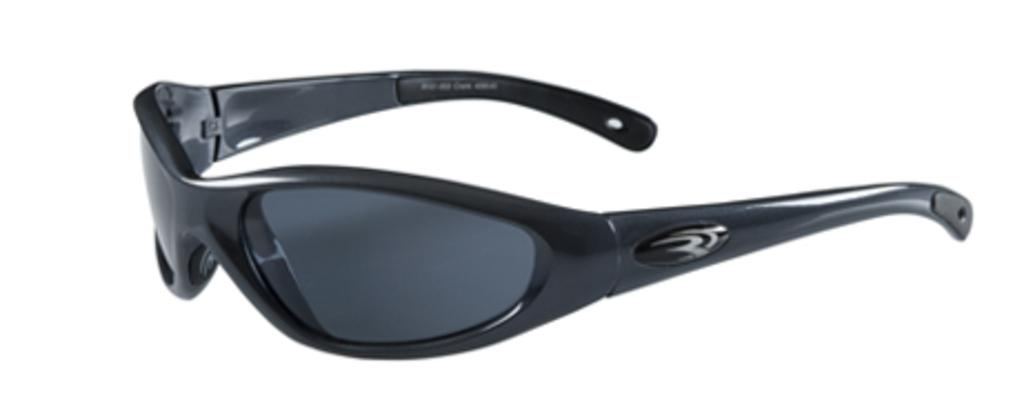What objects can be seen in the image? There are glasses in the image. What color is the background of the image? The background of the image is white. Can you see any veins in the lake depicted in the image? There is no lake present in the image, and therefore no veins can be seen in it. 